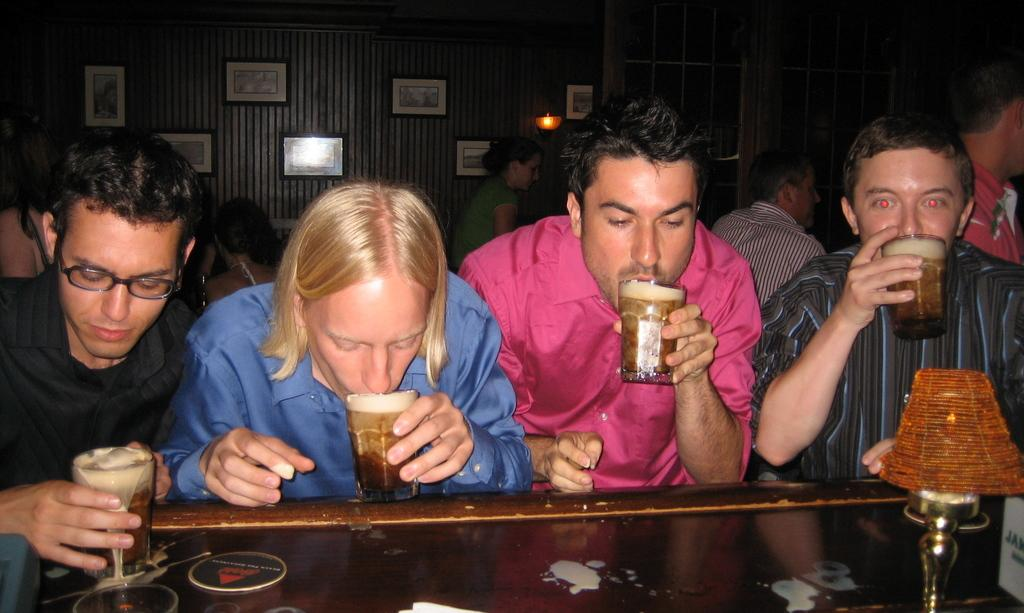What is happening with the group of people in the image? The people in the image are holding glasses and drinking wine. What can be seen in the background of the image? There is a curtain and a photo frame in the background of the image. What type of jewel is being used to open the wine bottle in the image? There is no jewel present in the image, and no wine bottle is being opened. 